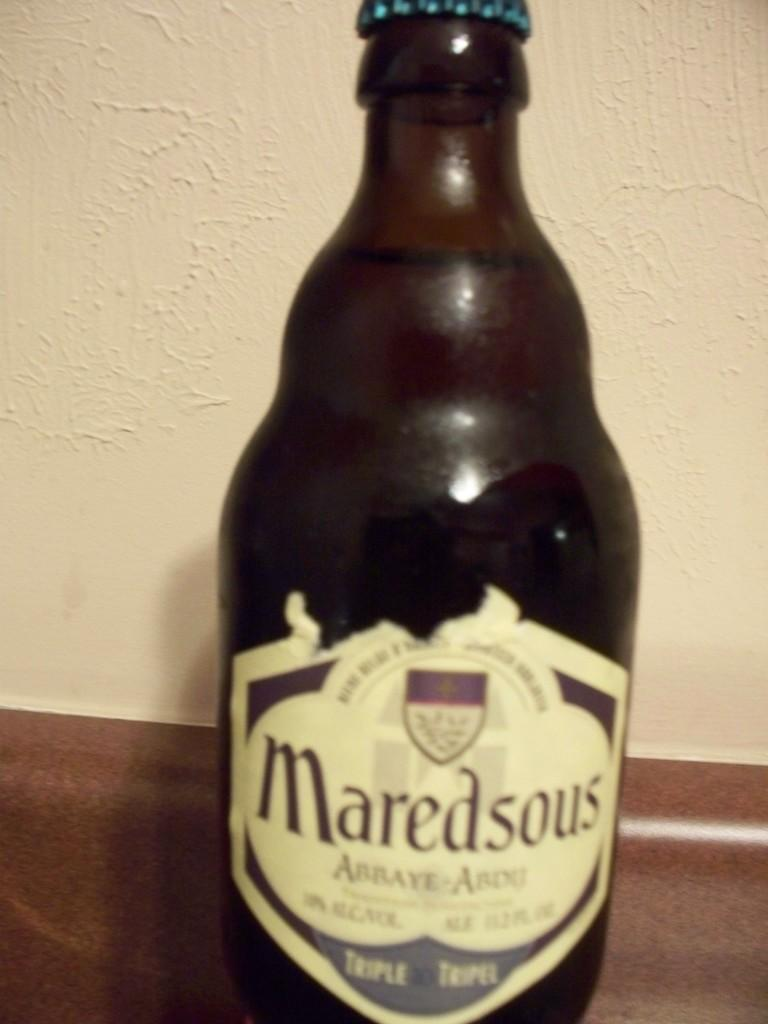<image>
Offer a succinct explanation of the picture presented. A closed glass bottle of a drink called Maredsous 